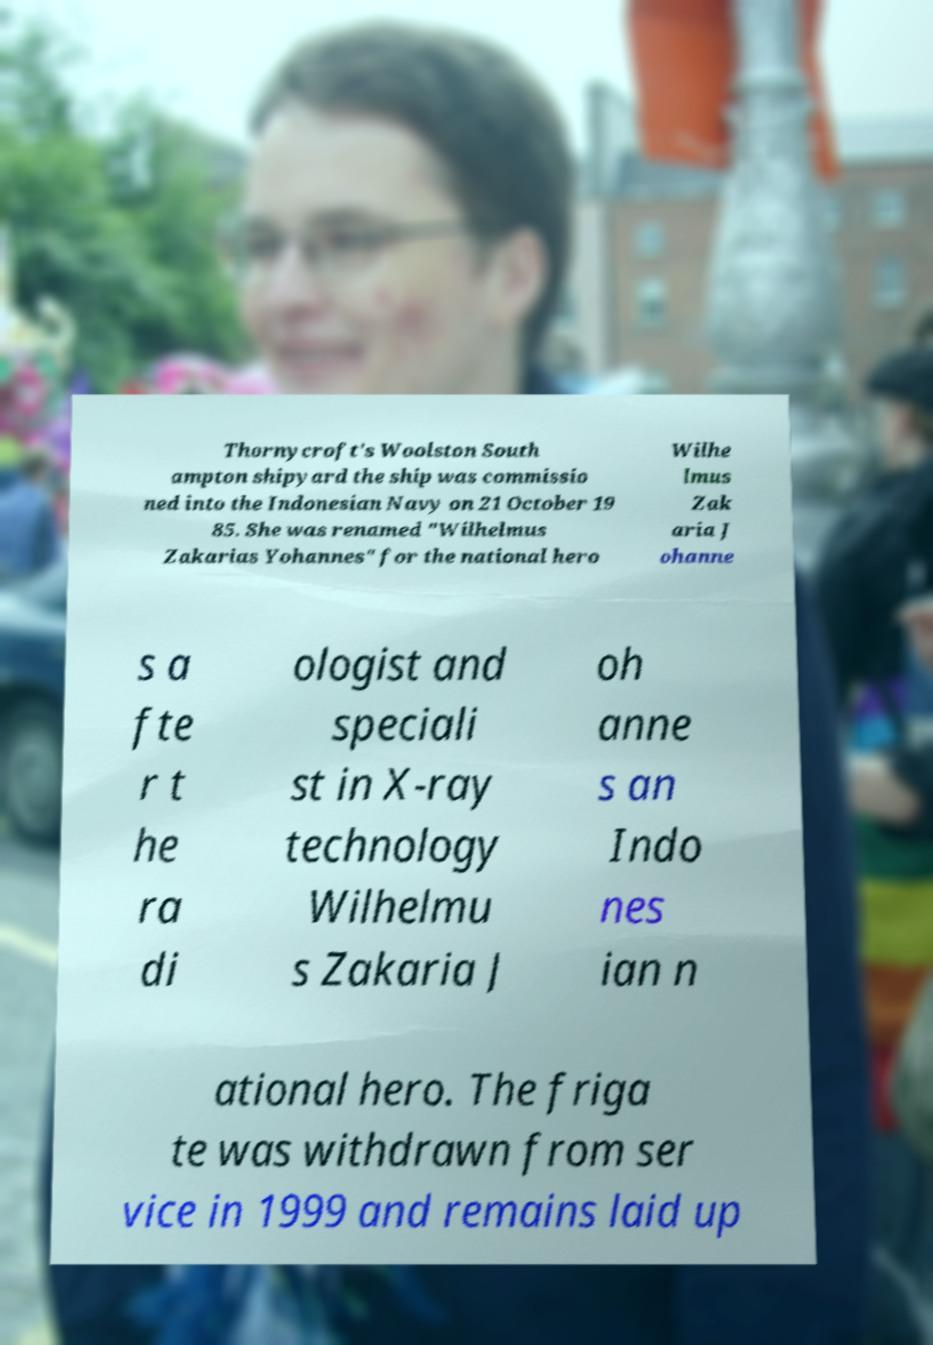Could you assist in decoding the text presented in this image and type it out clearly? Thornycroft's Woolston South ampton shipyard the ship was commissio ned into the Indonesian Navy on 21 October 19 85. She was renamed "Wilhelmus Zakarias Yohannes" for the national hero Wilhe lmus Zak aria J ohanne s a fte r t he ra di ologist and speciali st in X-ray technology Wilhelmu s Zakaria J oh anne s an Indo nes ian n ational hero. The friga te was withdrawn from ser vice in 1999 and remains laid up 